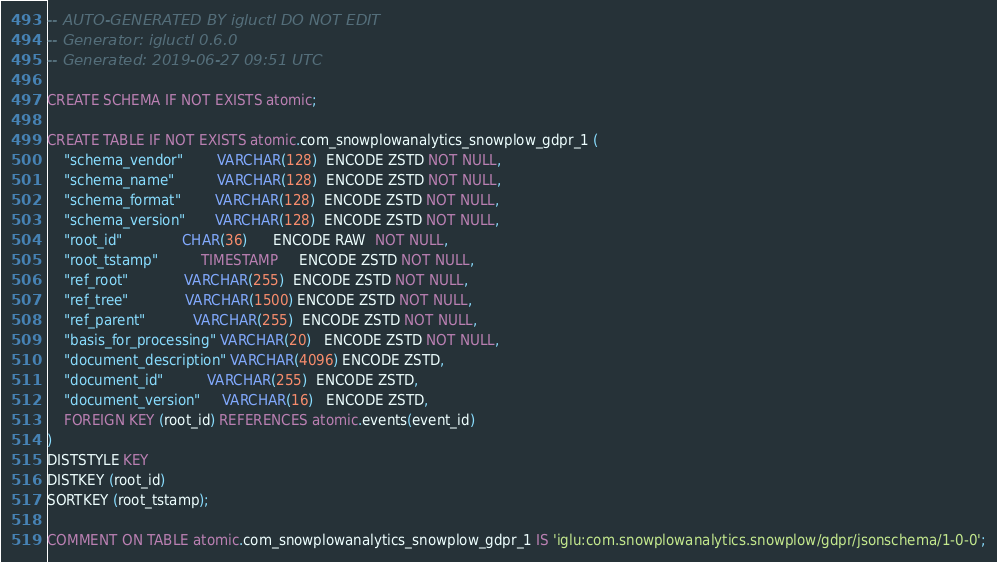Convert code to text. <code><loc_0><loc_0><loc_500><loc_500><_SQL_>-- AUTO-GENERATED BY igluctl DO NOT EDIT
-- Generator: igluctl 0.6.0
-- Generated: 2019-06-27 09:51 UTC

CREATE SCHEMA IF NOT EXISTS atomic;

CREATE TABLE IF NOT EXISTS atomic.com_snowplowanalytics_snowplow_gdpr_1 (
    "schema_vendor"        VARCHAR(128)  ENCODE ZSTD NOT NULL,
    "schema_name"          VARCHAR(128)  ENCODE ZSTD NOT NULL,
    "schema_format"        VARCHAR(128)  ENCODE ZSTD NOT NULL,
    "schema_version"       VARCHAR(128)  ENCODE ZSTD NOT NULL,
    "root_id"              CHAR(36)      ENCODE RAW  NOT NULL,
    "root_tstamp"          TIMESTAMP     ENCODE ZSTD NOT NULL,
    "ref_root"             VARCHAR(255)  ENCODE ZSTD NOT NULL,
    "ref_tree"             VARCHAR(1500) ENCODE ZSTD NOT NULL,
    "ref_parent"           VARCHAR(255)  ENCODE ZSTD NOT NULL,
    "basis_for_processing" VARCHAR(20)   ENCODE ZSTD NOT NULL,
    "document_description" VARCHAR(4096) ENCODE ZSTD,
    "document_id"          VARCHAR(255)  ENCODE ZSTD,
    "document_version"     VARCHAR(16)   ENCODE ZSTD,
    FOREIGN KEY (root_id) REFERENCES atomic.events(event_id)
)
DISTSTYLE KEY
DISTKEY (root_id)
SORTKEY (root_tstamp);

COMMENT ON TABLE atomic.com_snowplowanalytics_snowplow_gdpr_1 IS 'iglu:com.snowplowanalytics.snowplow/gdpr/jsonschema/1-0-0';
</code> 